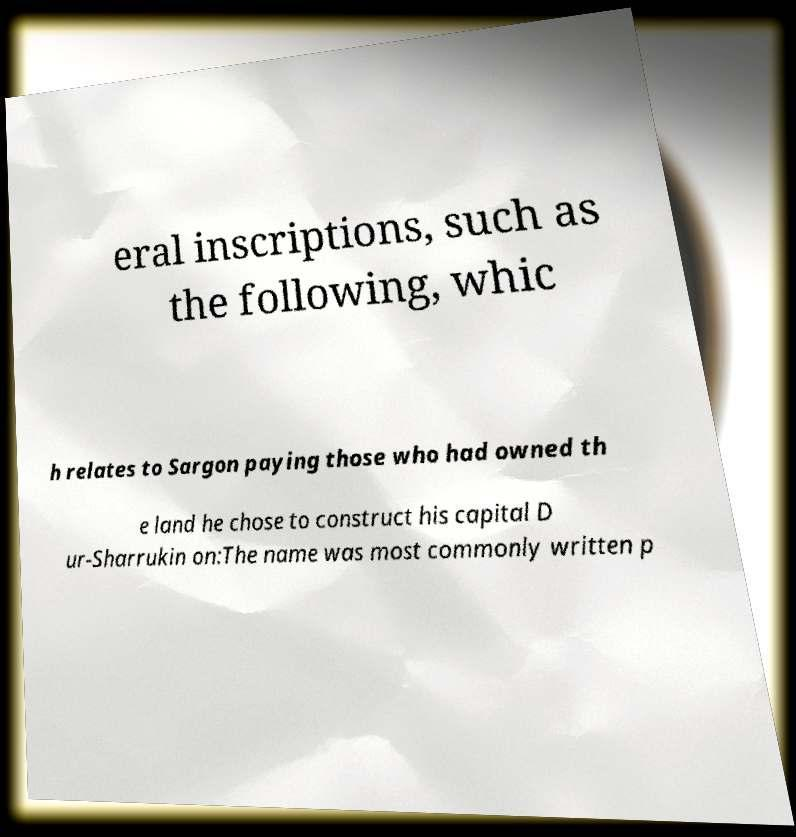Could you assist in decoding the text presented in this image and type it out clearly? eral inscriptions, such as the following, whic h relates to Sargon paying those who had owned th e land he chose to construct his capital D ur-Sharrukin on:The name was most commonly written p 